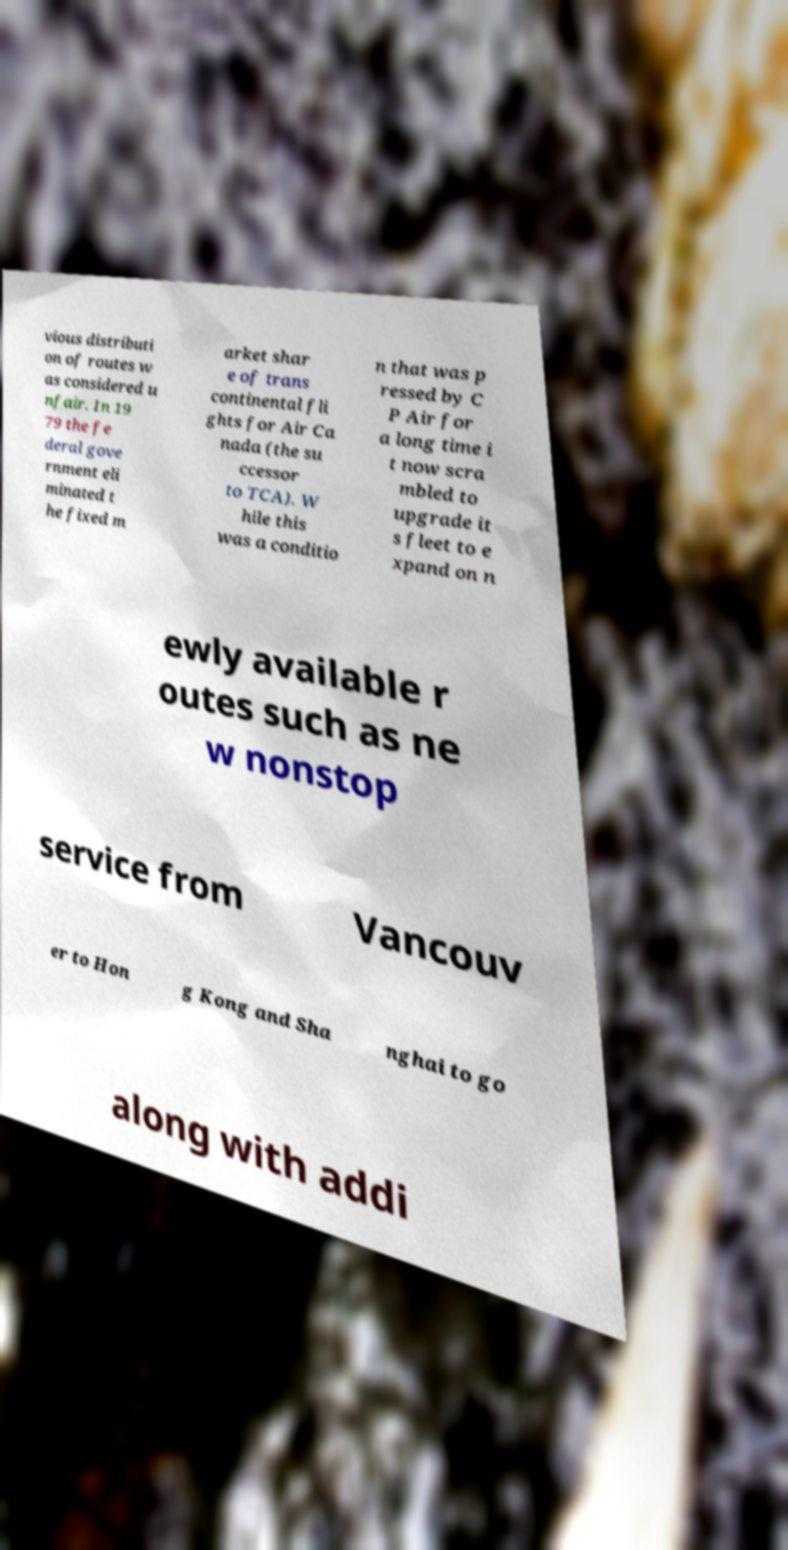There's text embedded in this image that I need extracted. Can you transcribe it verbatim? vious distributi on of routes w as considered u nfair. In 19 79 the fe deral gove rnment eli minated t he fixed m arket shar e of trans continental fli ghts for Air Ca nada (the su ccessor to TCA). W hile this was a conditio n that was p ressed by C P Air for a long time i t now scra mbled to upgrade it s fleet to e xpand on n ewly available r outes such as ne w nonstop service from Vancouv er to Hon g Kong and Sha nghai to go along with addi 